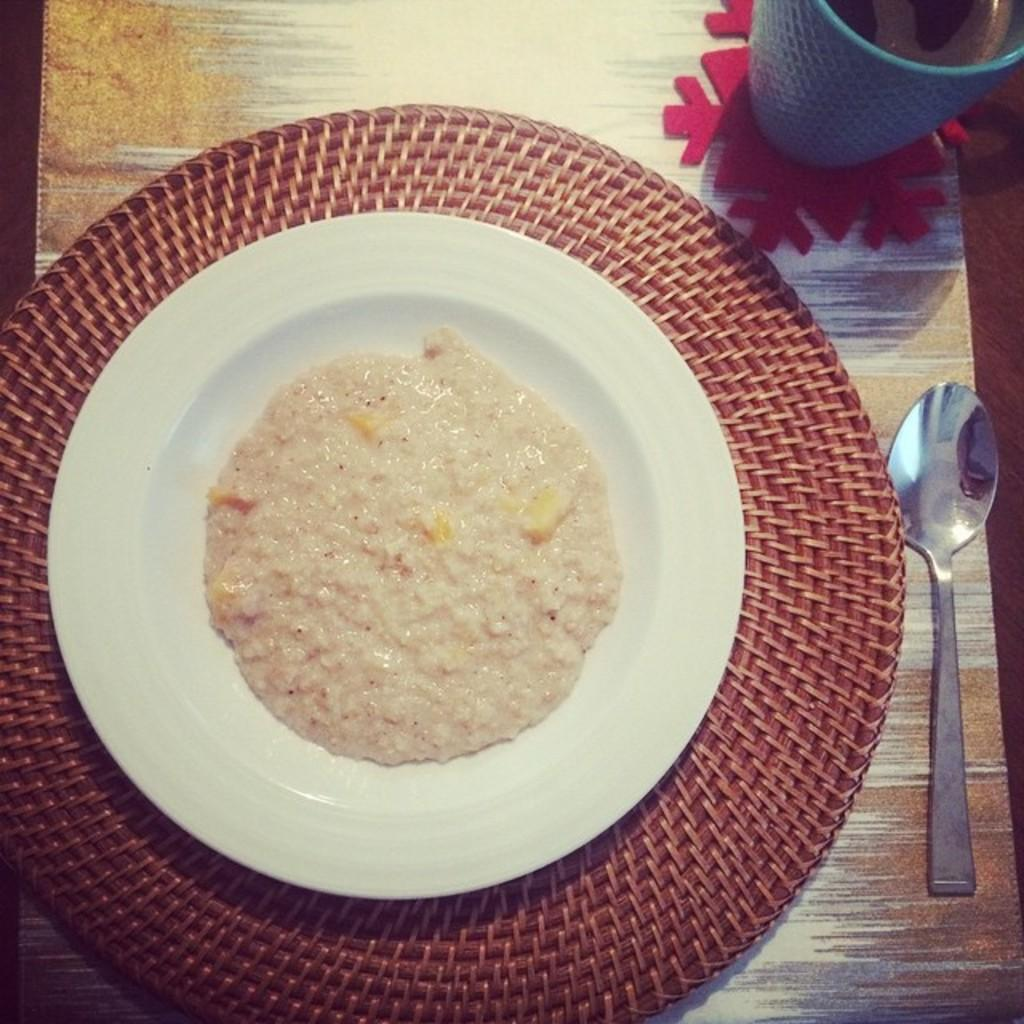What is the main food item on the plate in the image? The specific food item is not mentioned, but there is a food item on a plate on a table in the image. What utensil is present on the table? There is a spoon on the table. What else can be seen on the table besides the plate and spoon? There is a mug with a drink on the table. Where is the map located in the image? There is no map present in the image. How many clovers are on the plate in the image? There are no clovers present in the image. 